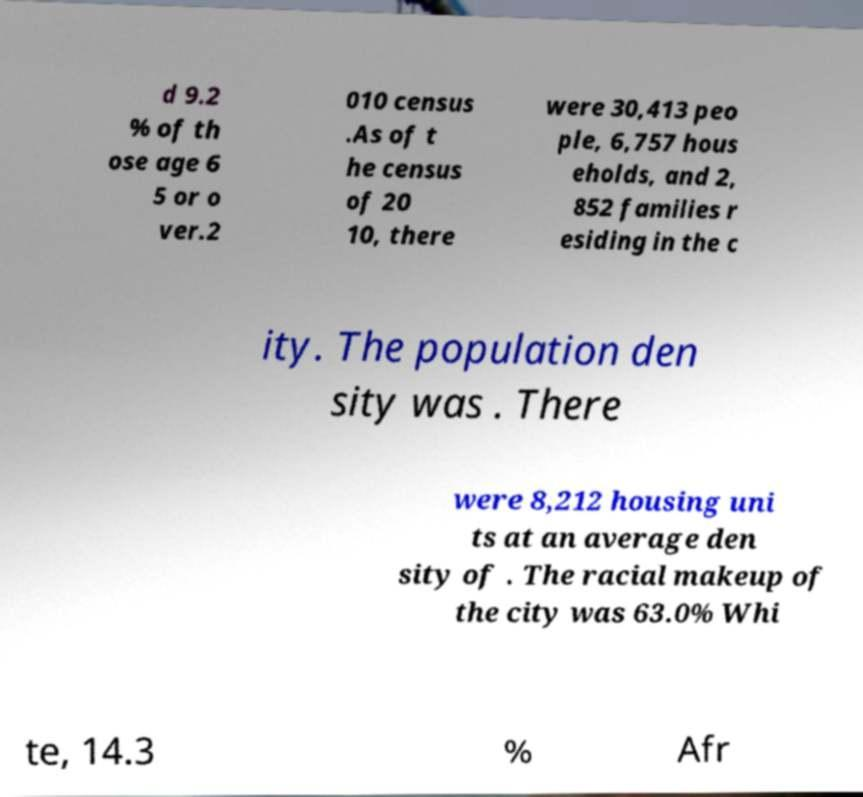I need the written content from this picture converted into text. Can you do that? d 9.2 % of th ose age 6 5 or o ver.2 010 census .As of t he census of 20 10, there were 30,413 peo ple, 6,757 hous eholds, and 2, 852 families r esiding in the c ity. The population den sity was . There were 8,212 housing uni ts at an average den sity of . The racial makeup of the city was 63.0% Whi te, 14.3 % Afr 